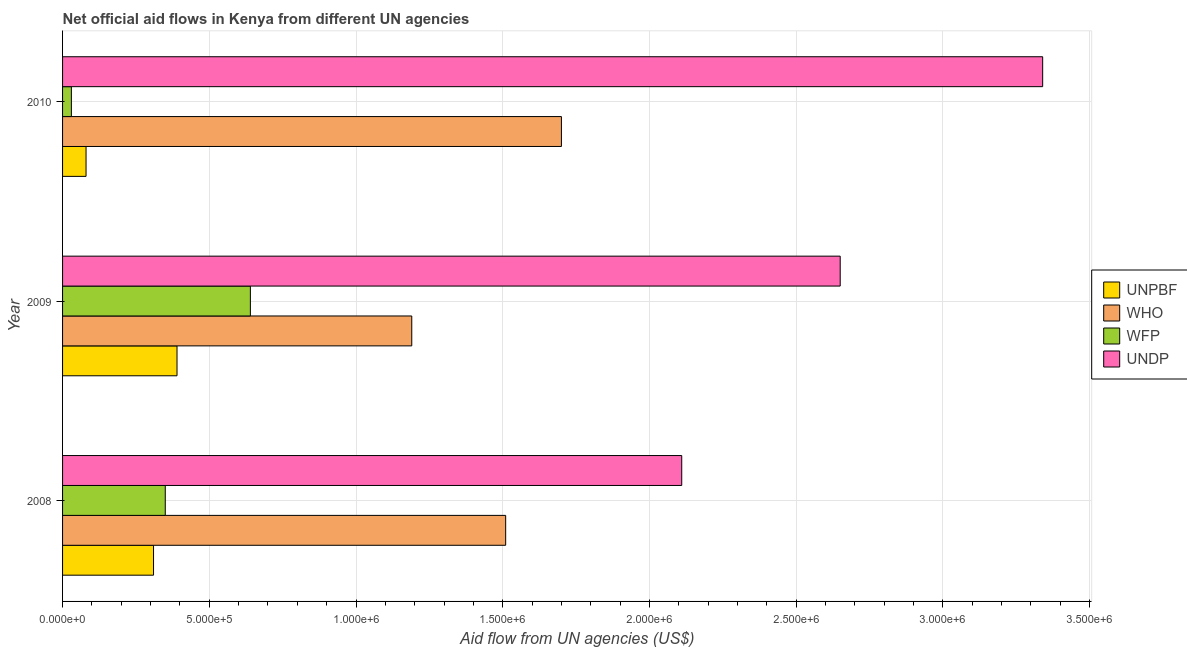How many different coloured bars are there?
Provide a succinct answer. 4. How many groups of bars are there?
Your answer should be compact. 3. What is the label of the 1st group of bars from the top?
Your response must be concise. 2010. What is the amount of aid given by undp in 2009?
Make the answer very short. 2.65e+06. Across all years, what is the maximum amount of aid given by unpbf?
Your answer should be very brief. 3.90e+05. Across all years, what is the minimum amount of aid given by who?
Give a very brief answer. 1.19e+06. In which year was the amount of aid given by unpbf maximum?
Keep it short and to the point. 2009. What is the total amount of aid given by who in the graph?
Your answer should be very brief. 4.40e+06. What is the difference between the amount of aid given by undp in 2009 and that in 2010?
Make the answer very short. -6.90e+05. What is the difference between the amount of aid given by undp in 2010 and the amount of aid given by unpbf in 2009?
Offer a terse response. 2.95e+06. In the year 2008, what is the difference between the amount of aid given by who and amount of aid given by wfp?
Provide a succinct answer. 1.16e+06. In how many years, is the amount of aid given by who greater than 3300000 US$?
Keep it short and to the point. 0. What is the ratio of the amount of aid given by who in 2008 to that in 2010?
Your response must be concise. 0.89. What is the difference between the highest and the second highest amount of aid given by wfp?
Keep it short and to the point. 2.90e+05. What is the difference between the highest and the lowest amount of aid given by undp?
Ensure brevity in your answer.  1.23e+06. Is the sum of the amount of aid given by wfp in 2008 and 2010 greater than the maximum amount of aid given by who across all years?
Offer a terse response. No. Is it the case that in every year, the sum of the amount of aid given by who and amount of aid given by unpbf is greater than the sum of amount of aid given by wfp and amount of aid given by undp?
Your answer should be very brief. No. What does the 2nd bar from the top in 2008 represents?
Your answer should be very brief. WFP. What does the 4th bar from the bottom in 2009 represents?
Your response must be concise. UNDP. Is it the case that in every year, the sum of the amount of aid given by unpbf and amount of aid given by who is greater than the amount of aid given by wfp?
Your response must be concise. Yes. How many bars are there?
Give a very brief answer. 12. Are all the bars in the graph horizontal?
Offer a very short reply. Yes. How many years are there in the graph?
Provide a short and direct response. 3. What is the difference between two consecutive major ticks on the X-axis?
Ensure brevity in your answer.  5.00e+05. Does the graph contain grids?
Your response must be concise. Yes. Where does the legend appear in the graph?
Give a very brief answer. Center right. How many legend labels are there?
Ensure brevity in your answer.  4. How are the legend labels stacked?
Provide a short and direct response. Vertical. What is the title of the graph?
Your response must be concise. Net official aid flows in Kenya from different UN agencies. What is the label or title of the X-axis?
Ensure brevity in your answer.  Aid flow from UN agencies (US$). What is the Aid flow from UN agencies (US$) of UNPBF in 2008?
Your response must be concise. 3.10e+05. What is the Aid flow from UN agencies (US$) of WHO in 2008?
Your response must be concise. 1.51e+06. What is the Aid flow from UN agencies (US$) in WFP in 2008?
Your answer should be very brief. 3.50e+05. What is the Aid flow from UN agencies (US$) of UNDP in 2008?
Make the answer very short. 2.11e+06. What is the Aid flow from UN agencies (US$) of UNPBF in 2009?
Provide a succinct answer. 3.90e+05. What is the Aid flow from UN agencies (US$) of WHO in 2009?
Make the answer very short. 1.19e+06. What is the Aid flow from UN agencies (US$) of WFP in 2009?
Your response must be concise. 6.40e+05. What is the Aid flow from UN agencies (US$) in UNDP in 2009?
Your response must be concise. 2.65e+06. What is the Aid flow from UN agencies (US$) of WHO in 2010?
Ensure brevity in your answer.  1.70e+06. What is the Aid flow from UN agencies (US$) in UNDP in 2010?
Your response must be concise. 3.34e+06. Across all years, what is the maximum Aid flow from UN agencies (US$) in WHO?
Your response must be concise. 1.70e+06. Across all years, what is the maximum Aid flow from UN agencies (US$) of WFP?
Offer a very short reply. 6.40e+05. Across all years, what is the maximum Aid flow from UN agencies (US$) in UNDP?
Give a very brief answer. 3.34e+06. Across all years, what is the minimum Aid flow from UN agencies (US$) of UNPBF?
Offer a terse response. 8.00e+04. Across all years, what is the minimum Aid flow from UN agencies (US$) in WHO?
Make the answer very short. 1.19e+06. Across all years, what is the minimum Aid flow from UN agencies (US$) in WFP?
Your answer should be very brief. 3.00e+04. Across all years, what is the minimum Aid flow from UN agencies (US$) in UNDP?
Give a very brief answer. 2.11e+06. What is the total Aid flow from UN agencies (US$) in UNPBF in the graph?
Give a very brief answer. 7.80e+05. What is the total Aid flow from UN agencies (US$) in WHO in the graph?
Make the answer very short. 4.40e+06. What is the total Aid flow from UN agencies (US$) in WFP in the graph?
Make the answer very short. 1.02e+06. What is the total Aid flow from UN agencies (US$) of UNDP in the graph?
Make the answer very short. 8.10e+06. What is the difference between the Aid flow from UN agencies (US$) in WFP in 2008 and that in 2009?
Your response must be concise. -2.90e+05. What is the difference between the Aid flow from UN agencies (US$) in UNDP in 2008 and that in 2009?
Ensure brevity in your answer.  -5.40e+05. What is the difference between the Aid flow from UN agencies (US$) in WFP in 2008 and that in 2010?
Keep it short and to the point. 3.20e+05. What is the difference between the Aid flow from UN agencies (US$) of UNDP in 2008 and that in 2010?
Your answer should be compact. -1.23e+06. What is the difference between the Aid flow from UN agencies (US$) in UNPBF in 2009 and that in 2010?
Give a very brief answer. 3.10e+05. What is the difference between the Aid flow from UN agencies (US$) in WHO in 2009 and that in 2010?
Give a very brief answer. -5.10e+05. What is the difference between the Aid flow from UN agencies (US$) of UNDP in 2009 and that in 2010?
Give a very brief answer. -6.90e+05. What is the difference between the Aid flow from UN agencies (US$) of UNPBF in 2008 and the Aid flow from UN agencies (US$) of WHO in 2009?
Your answer should be compact. -8.80e+05. What is the difference between the Aid flow from UN agencies (US$) in UNPBF in 2008 and the Aid flow from UN agencies (US$) in WFP in 2009?
Give a very brief answer. -3.30e+05. What is the difference between the Aid flow from UN agencies (US$) in UNPBF in 2008 and the Aid flow from UN agencies (US$) in UNDP in 2009?
Ensure brevity in your answer.  -2.34e+06. What is the difference between the Aid flow from UN agencies (US$) of WHO in 2008 and the Aid flow from UN agencies (US$) of WFP in 2009?
Offer a terse response. 8.70e+05. What is the difference between the Aid flow from UN agencies (US$) in WHO in 2008 and the Aid flow from UN agencies (US$) in UNDP in 2009?
Ensure brevity in your answer.  -1.14e+06. What is the difference between the Aid flow from UN agencies (US$) of WFP in 2008 and the Aid flow from UN agencies (US$) of UNDP in 2009?
Offer a very short reply. -2.30e+06. What is the difference between the Aid flow from UN agencies (US$) of UNPBF in 2008 and the Aid flow from UN agencies (US$) of WHO in 2010?
Ensure brevity in your answer.  -1.39e+06. What is the difference between the Aid flow from UN agencies (US$) in UNPBF in 2008 and the Aid flow from UN agencies (US$) in WFP in 2010?
Ensure brevity in your answer.  2.80e+05. What is the difference between the Aid flow from UN agencies (US$) in UNPBF in 2008 and the Aid flow from UN agencies (US$) in UNDP in 2010?
Your answer should be very brief. -3.03e+06. What is the difference between the Aid flow from UN agencies (US$) of WHO in 2008 and the Aid flow from UN agencies (US$) of WFP in 2010?
Your response must be concise. 1.48e+06. What is the difference between the Aid flow from UN agencies (US$) of WHO in 2008 and the Aid flow from UN agencies (US$) of UNDP in 2010?
Provide a short and direct response. -1.83e+06. What is the difference between the Aid flow from UN agencies (US$) in WFP in 2008 and the Aid flow from UN agencies (US$) in UNDP in 2010?
Make the answer very short. -2.99e+06. What is the difference between the Aid flow from UN agencies (US$) of UNPBF in 2009 and the Aid flow from UN agencies (US$) of WHO in 2010?
Your answer should be very brief. -1.31e+06. What is the difference between the Aid flow from UN agencies (US$) in UNPBF in 2009 and the Aid flow from UN agencies (US$) in UNDP in 2010?
Keep it short and to the point. -2.95e+06. What is the difference between the Aid flow from UN agencies (US$) in WHO in 2009 and the Aid flow from UN agencies (US$) in WFP in 2010?
Provide a short and direct response. 1.16e+06. What is the difference between the Aid flow from UN agencies (US$) of WHO in 2009 and the Aid flow from UN agencies (US$) of UNDP in 2010?
Provide a short and direct response. -2.15e+06. What is the difference between the Aid flow from UN agencies (US$) in WFP in 2009 and the Aid flow from UN agencies (US$) in UNDP in 2010?
Make the answer very short. -2.70e+06. What is the average Aid flow from UN agencies (US$) of WHO per year?
Make the answer very short. 1.47e+06. What is the average Aid flow from UN agencies (US$) of WFP per year?
Ensure brevity in your answer.  3.40e+05. What is the average Aid flow from UN agencies (US$) of UNDP per year?
Ensure brevity in your answer.  2.70e+06. In the year 2008, what is the difference between the Aid flow from UN agencies (US$) in UNPBF and Aid flow from UN agencies (US$) in WHO?
Provide a short and direct response. -1.20e+06. In the year 2008, what is the difference between the Aid flow from UN agencies (US$) of UNPBF and Aid flow from UN agencies (US$) of UNDP?
Your answer should be compact. -1.80e+06. In the year 2008, what is the difference between the Aid flow from UN agencies (US$) of WHO and Aid flow from UN agencies (US$) of WFP?
Your answer should be compact. 1.16e+06. In the year 2008, what is the difference between the Aid flow from UN agencies (US$) in WHO and Aid flow from UN agencies (US$) in UNDP?
Make the answer very short. -6.00e+05. In the year 2008, what is the difference between the Aid flow from UN agencies (US$) in WFP and Aid flow from UN agencies (US$) in UNDP?
Provide a succinct answer. -1.76e+06. In the year 2009, what is the difference between the Aid flow from UN agencies (US$) of UNPBF and Aid flow from UN agencies (US$) of WHO?
Provide a short and direct response. -8.00e+05. In the year 2009, what is the difference between the Aid flow from UN agencies (US$) of UNPBF and Aid flow from UN agencies (US$) of WFP?
Offer a terse response. -2.50e+05. In the year 2009, what is the difference between the Aid flow from UN agencies (US$) in UNPBF and Aid flow from UN agencies (US$) in UNDP?
Offer a terse response. -2.26e+06. In the year 2009, what is the difference between the Aid flow from UN agencies (US$) of WHO and Aid flow from UN agencies (US$) of UNDP?
Your response must be concise. -1.46e+06. In the year 2009, what is the difference between the Aid flow from UN agencies (US$) in WFP and Aid flow from UN agencies (US$) in UNDP?
Your answer should be compact. -2.01e+06. In the year 2010, what is the difference between the Aid flow from UN agencies (US$) in UNPBF and Aid flow from UN agencies (US$) in WHO?
Your response must be concise. -1.62e+06. In the year 2010, what is the difference between the Aid flow from UN agencies (US$) in UNPBF and Aid flow from UN agencies (US$) in WFP?
Your answer should be very brief. 5.00e+04. In the year 2010, what is the difference between the Aid flow from UN agencies (US$) of UNPBF and Aid flow from UN agencies (US$) of UNDP?
Give a very brief answer. -3.26e+06. In the year 2010, what is the difference between the Aid flow from UN agencies (US$) in WHO and Aid flow from UN agencies (US$) in WFP?
Your answer should be very brief. 1.67e+06. In the year 2010, what is the difference between the Aid flow from UN agencies (US$) in WHO and Aid flow from UN agencies (US$) in UNDP?
Offer a terse response. -1.64e+06. In the year 2010, what is the difference between the Aid flow from UN agencies (US$) in WFP and Aid flow from UN agencies (US$) in UNDP?
Provide a succinct answer. -3.31e+06. What is the ratio of the Aid flow from UN agencies (US$) in UNPBF in 2008 to that in 2009?
Offer a terse response. 0.79. What is the ratio of the Aid flow from UN agencies (US$) of WHO in 2008 to that in 2009?
Your answer should be very brief. 1.27. What is the ratio of the Aid flow from UN agencies (US$) of WFP in 2008 to that in 2009?
Your answer should be compact. 0.55. What is the ratio of the Aid flow from UN agencies (US$) of UNDP in 2008 to that in 2009?
Keep it short and to the point. 0.8. What is the ratio of the Aid flow from UN agencies (US$) in UNPBF in 2008 to that in 2010?
Provide a short and direct response. 3.88. What is the ratio of the Aid flow from UN agencies (US$) of WHO in 2008 to that in 2010?
Ensure brevity in your answer.  0.89. What is the ratio of the Aid flow from UN agencies (US$) in WFP in 2008 to that in 2010?
Offer a very short reply. 11.67. What is the ratio of the Aid flow from UN agencies (US$) of UNDP in 2008 to that in 2010?
Provide a succinct answer. 0.63. What is the ratio of the Aid flow from UN agencies (US$) of UNPBF in 2009 to that in 2010?
Provide a succinct answer. 4.88. What is the ratio of the Aid flow from UN agencies (US$) of WHO in 2009 to that in 2010?
Give a very brief answer. 0.7. What is the ratio of the Aid flow from UN agencies (US$) in WFP in 2009 to that in 2010?
Provide a short and direct response. 21.33. What is the ratio of the Aid flow from UN agencies (US$) in UNDP in 2009 to that in 2010?
Provide a short and direct response. 0.79. What is the difference between the highest and the second highest Aid flow from UN agencies (US$) of WHO?
Ensure brevity in your answer.  1.90e+05. What is the difference between the highest and the second highest Aid flow from UN agencies (US$) in WFP?
Your answer should be very brief. 2.90e+05. What is the difference between the highest and the second highest Aid flow from UN agencies (US$) in UNDP?
Offer a very short reply. 6.90e+05. What is the difference between the highest and the lowest Aid flow from UN agencies (US$) of WHO?
Offer a very short reply. 5.10e+05. What is the difference between the highest and the lowest Aid flow from UN agencies (US$) of WFP?
Make the answer very short. 6.10e+05. What is the difference between the highest and the lowest Aid flow from UN agencies (US$) in UNDP?
Give a very brief answer. 1.23e+06. 